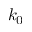Convert formula to latex. <formula><loc_0><loc_0><loc_500><loc_500>k _ { 0 }</formula> 